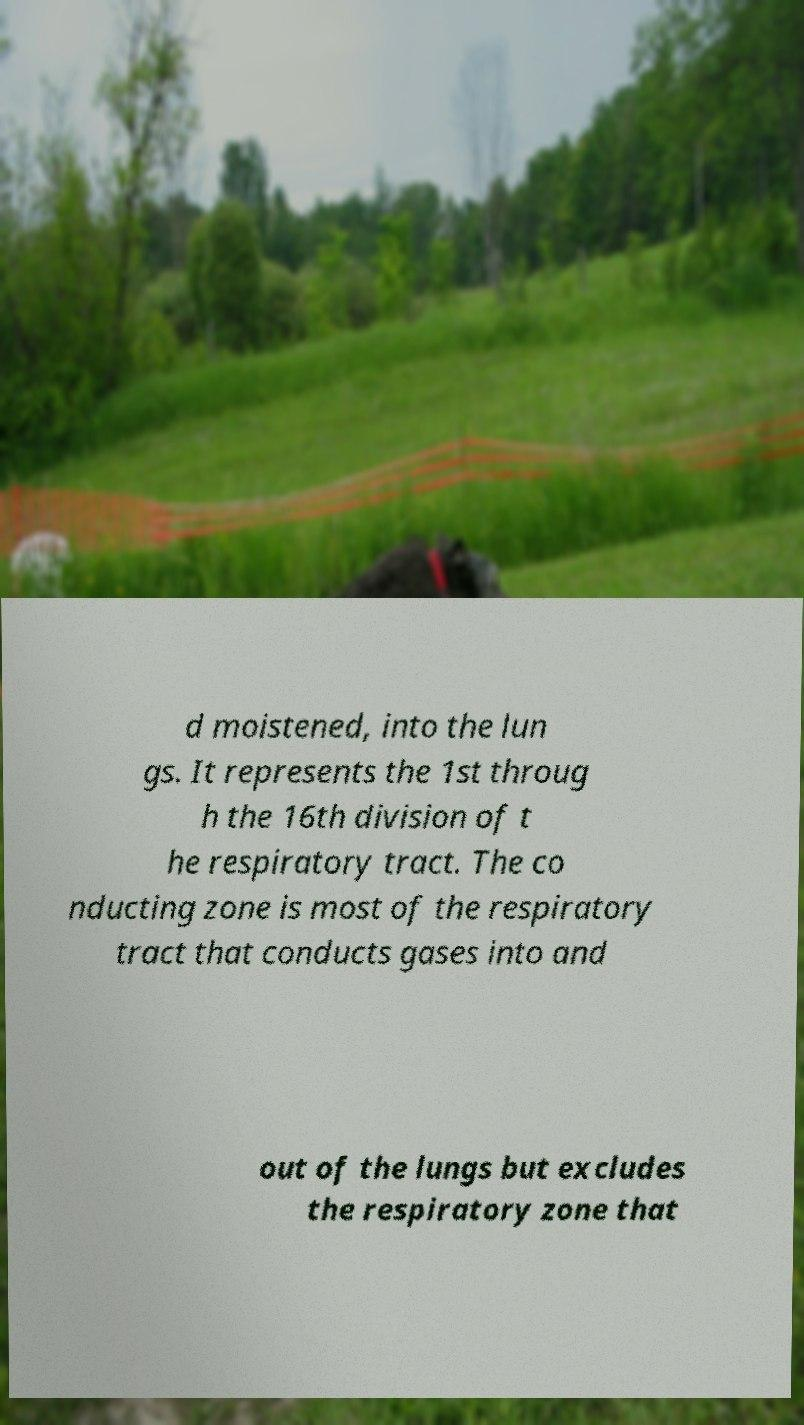For documentation purposes, I need the text within this image transcribed. Could you provide that? d moistened, into the lun gs. It represents the 1st throug h the 16th division of t he respiratory tract. The co nducting zone is most of the respiratory tract that conducts gases into and out of the lungs but excludes the respiratory zone that 